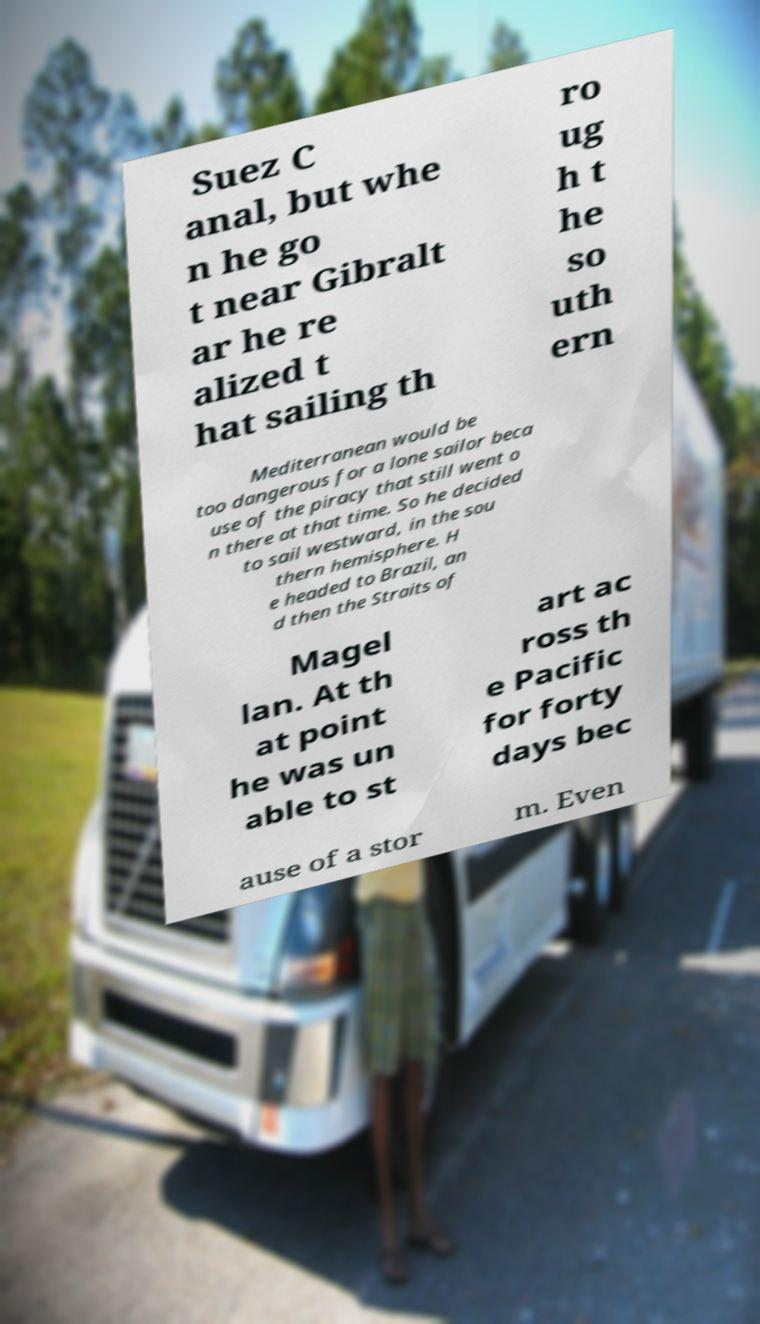Please read and relay the text visible in this image. What does it say? Suez C anal, but whe n he go t near Gibralt ar he re alized t hat sailing th ro ug h t he so uth ern Mediterranean would be too dangerous for a lone sailor beca use of the piracy that still went o n there at that time. So he decided to sail westward, in the sou thern hemisphere. H e headed to Brazil, an d then the Straits of Magel lan. At th at point he was un able to st art ac ross th e Pacific for forty days bec ause of a stor m. Even 